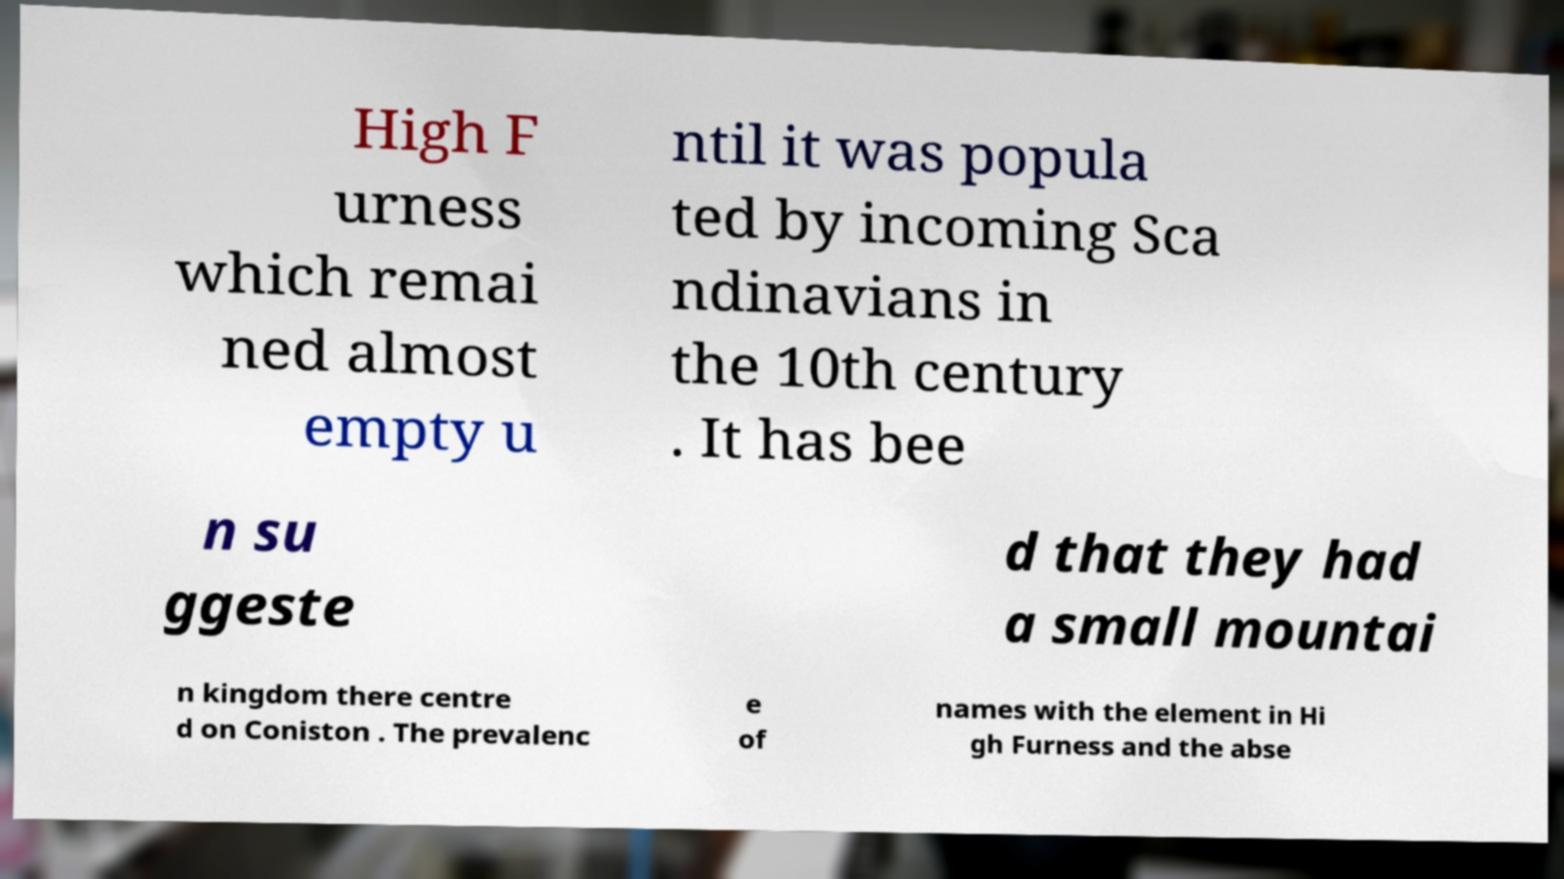For documentation purposes, I need the text within this image transcribed. Could you provide that? High F urness which remai ned almost empty u ntil it was popula ted by incoming Sca ndinavians in the 10th century . It has bee n su ggeste d that they had a small mountai n kingdom there centre d on Coniston . The prevalenc e of names with the element in Hi gh Furness and the abse 